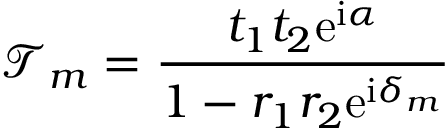Convert formula to latex. <formula><loc_0><loc_0><loc_500><loc_500>\mathcal { T } _ { m } = \frac { t _ { 1 } t _ { 2 } e ^ { i \alpha } } { 1 - r _ { 1 } r _ { 2 } e ^ { i \delta _ { m } } }</formula> 